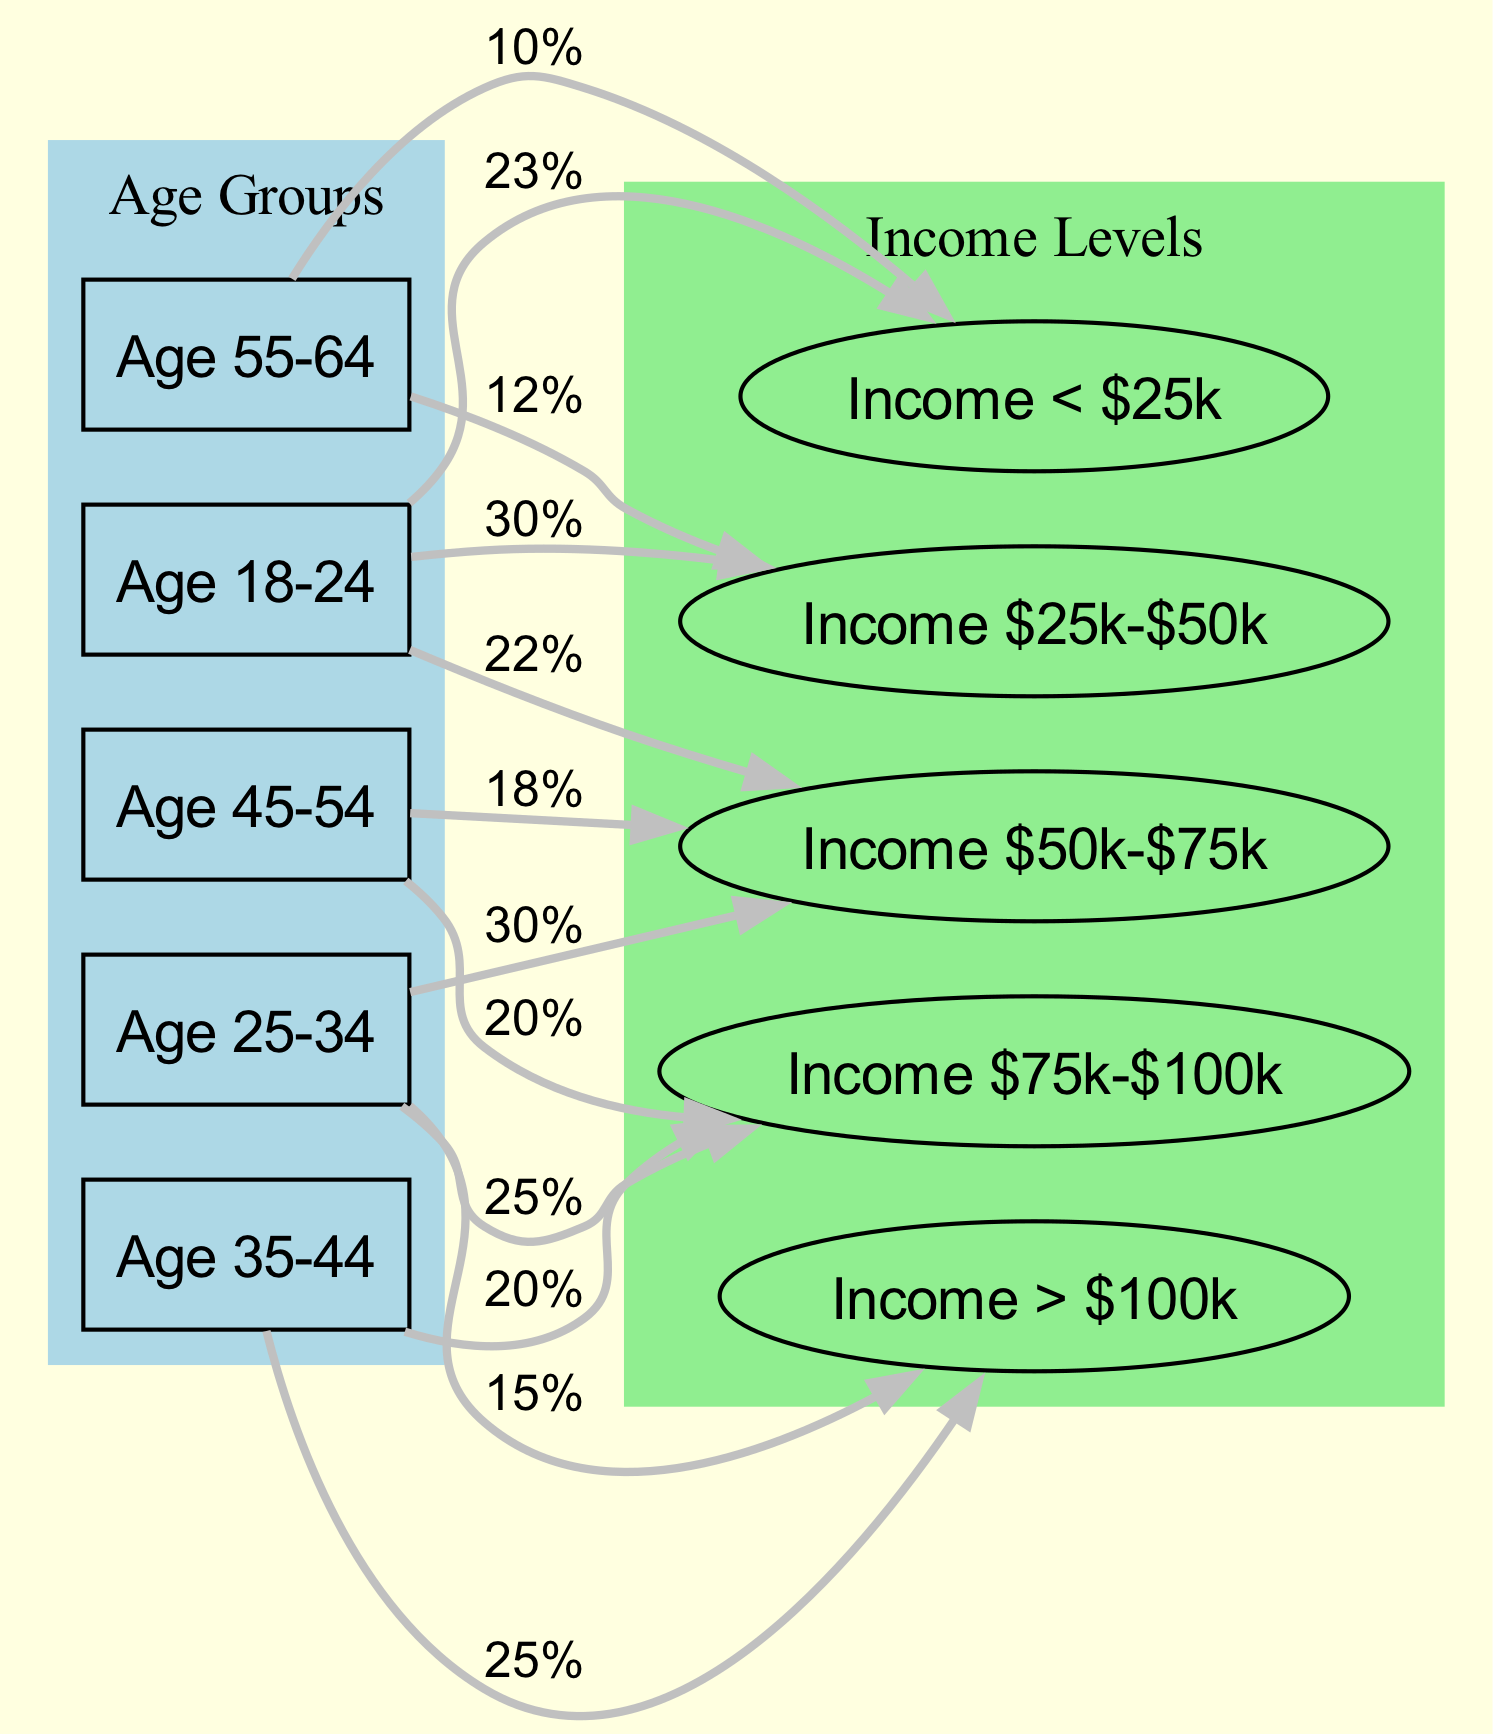What percentage of the 18-24 age group has an income of $25k-$50k? According to the diagram, the edge from the "Age Group 18-24" node to the "Income $25k-$50k" node is labeled "30%." This indicates that 30% of individuals in the 18-24 age group have this income level.
Answer: 30% How many age groups are represented in the diagram? The diagram includes five distinct age group nodes: Age 18-24, Age 25-34, Age 35-44, Age 45-54, and Age 55-64. Therefore, there are five age groups represented.
Answer: 5 What income level has the highest percentage among the 35-44 age group? The diagram shows that the "Income > $100k" node from the "Age Group 35-44" node is labeled "25%," which is the highest value for this age group when compared to other income levels.
Answer: 25% Which age group has the lowest percentage in the income level under 25k? The "Income < $25k" node is linked to the "Age Group 55-64," with a label of "10%." This is the only connection to the income level under 25k; thus, it is the lowest percentage in that category.
Answer: Age 55-64 What is the total percentage of the 25-34 age group in the income level of $50k-$75k? The edge connecting the "Age Group 25-34" to "Income $50k-$75k" has a label of "30%." This means that 30% of the 25-34 age group fits within this income level.
Answer: 30% Which income level is most associated with the age group of 45-54? The diagram shows two connections from the "Age Group 45-54" node: one to "Income $50k-$75k" with a label of "18%" and another to "Income $75k-$100k" with a label of "20%." The connection with the highest percentage is to the income level of $75k-$100k.
Answer: $75k-$100k How many nodes represent income levels in the diagram? There are five nodes that represent different income levels: Income < $25k, Income $25k-$50k, Income $50k-$75k, Income $75k-$100k, and Income > $100k. Thus, the total number of income level nodes is five.
Answer: 5 What is the combined percentage of the 18-24 age group for all income levels? The diagram provides percentages for the connections from the "Age Group 18-24": 23% (Income < $25k), 30% (Income $25k-$50k), and 22% (Income $50k-$75k). Adding these up gives 23% + 30% + 22% = 75%.
Answer: 75% 